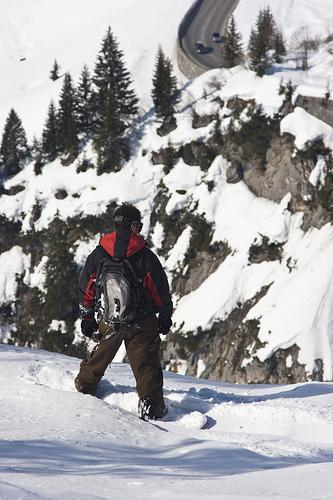What is near the trees? Please explain your reasoning. snow. There is white all around them 